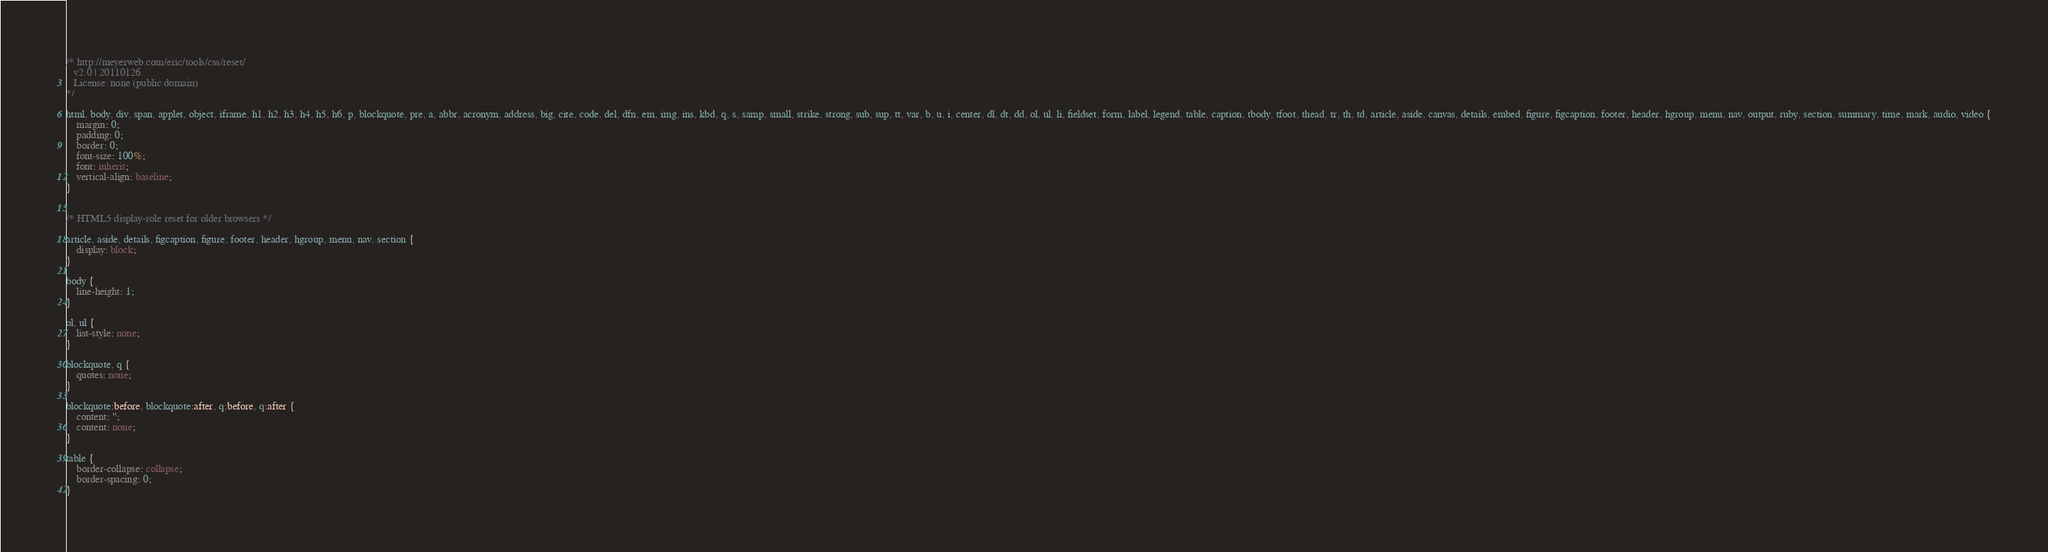<code> <loc_0><loc_0><loc_500><loc_500><_CSS_>/* http://meyerweb.com/eric/tools/css/reset/ 
   v2.0 | 20110126
   License: none (public domain)
*/

html, body, div, span, applet, object, iframe, h1, h2, h3, h4, h5, h6, p, blockquote, pre, a, abbr, acronym, address, big, cite, code, del, dfn, em, img, ins, kbd, q, s, samp, small, strike, strong, sub, sup, tt, var, b, u, i, center, dl, dt, dd, ol, ul, li, fieldset, form, label, legend, table, caption, tbody, tfoot, thead, tr, th, td, article, aside, canvas, details, embed, figure, figcaption, footer, header, hgroup, menu, nav, output, ruby, section, summary, time, mark, audio, video {
    margin: 0;
    padding: 0;
    border: 0;
    font-size: 100%;
    font: inherit;
    vertical-align: baseline;
}


/* HTML5 display-role reset for older browsers */

article, aside, details, figcaption, figure, footer, header, hgroup, menu, nav, section {
    display: block;
}

body {
    line-height: 1;
}

ol, ul {
    list-style: none;
}

blockquote, q {
    quotes: none;
}

blockquote:before, blockquote:after, q:before, q:after {
    content: '';
    content: none;
}

table {
    border-collapse: collapse;
    border-spacing: 0;
}</code> 